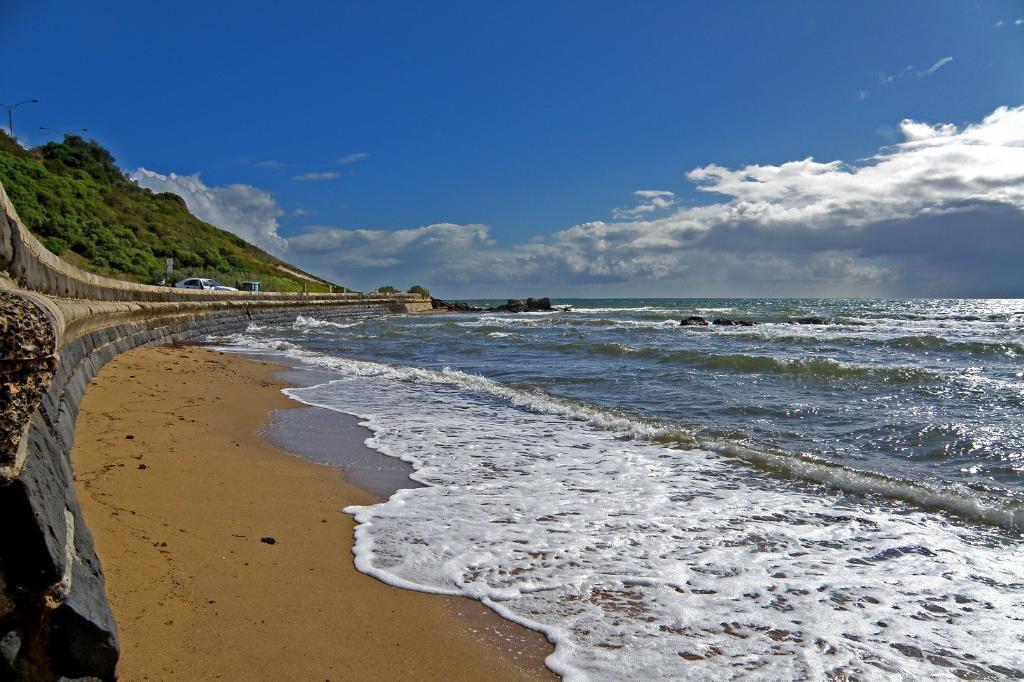How would you summarize this image in a sentence or two? In this image we can see ocean, mountain, sand, sky and clouds. 